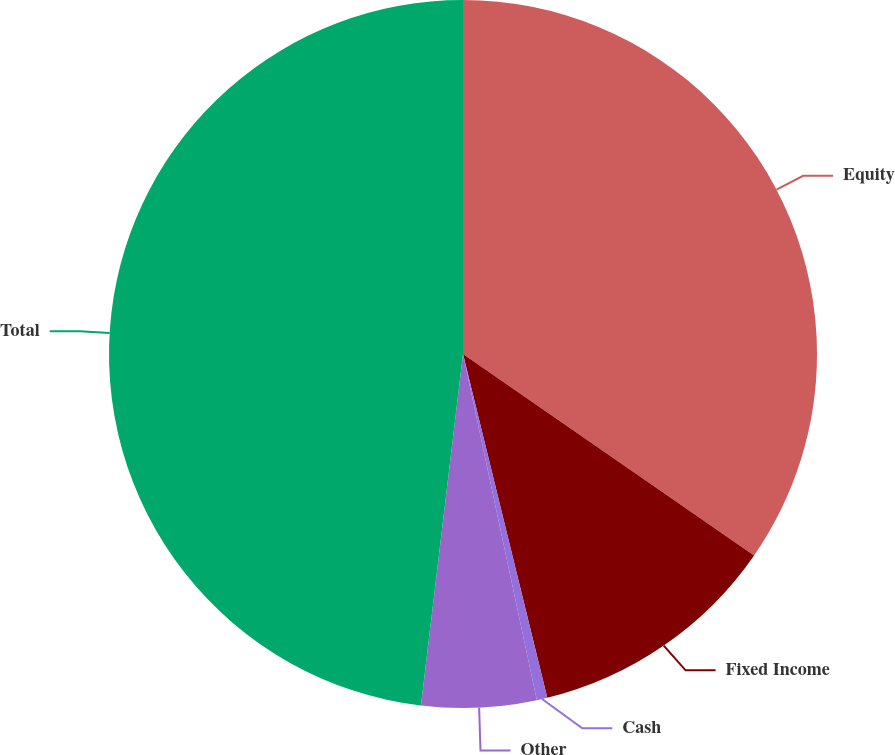<chart> <loc_0><loc_0><loc_500><loc_500><pie_chart><fcel>Equity<fcel>Fixed Income<fcel>Cash<fcel>Other<fcel>Total<nl><fcel>34.63%<fcel>11.54%<fcel>0.48%<fcel>5.24%<fcel>48.1%<nl></chart> 